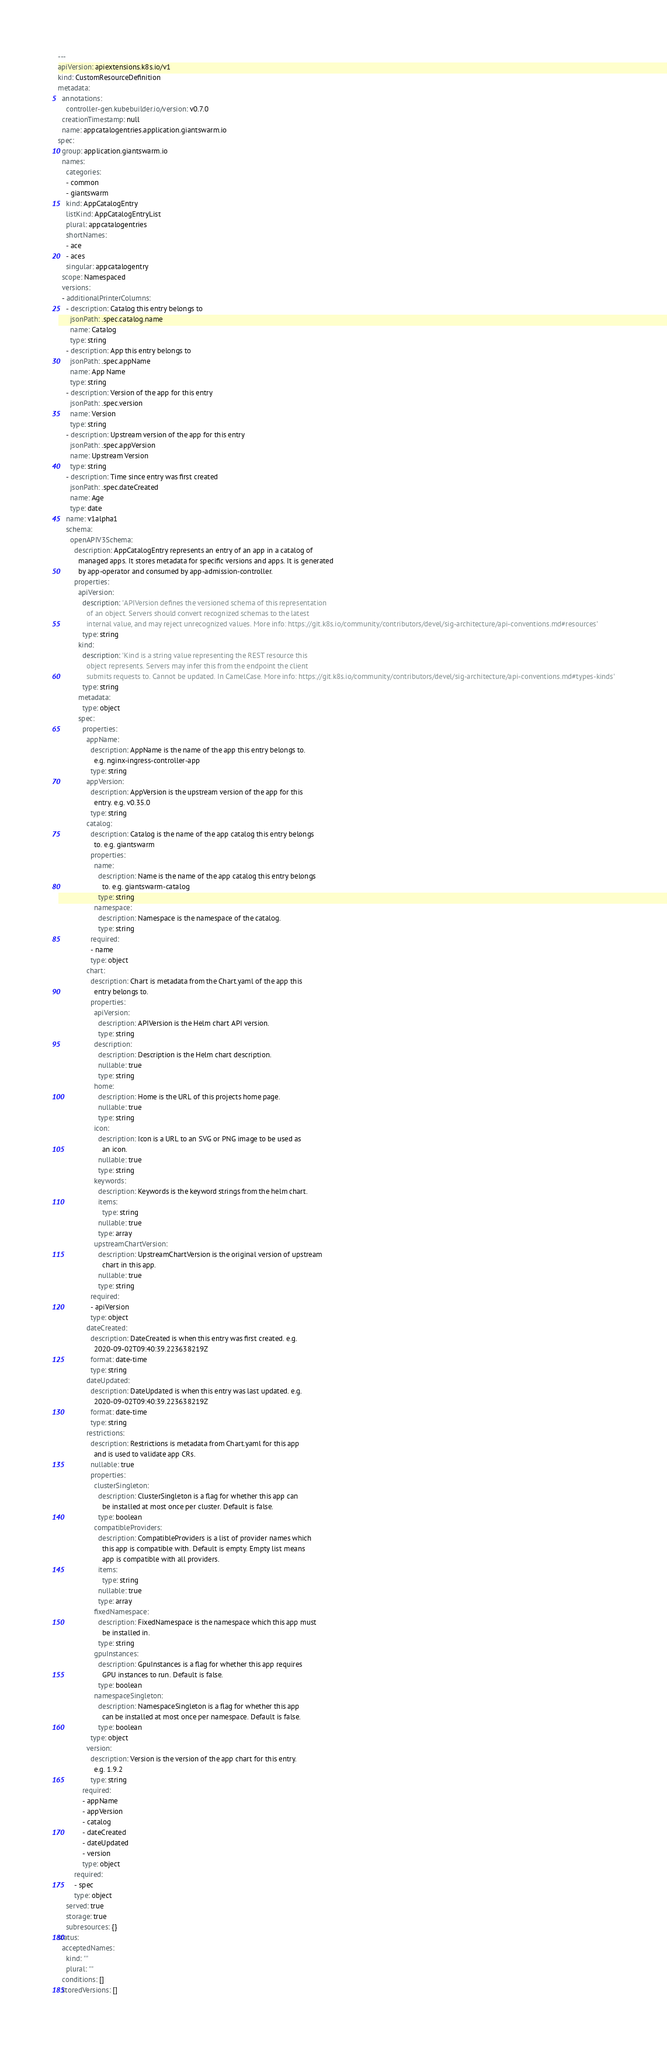<code> <loc_0><loc_0><loc_500><loc_500><_YAML_>
---
apiVersion: apiextensions.k8s.io/v1
kind: CustomResourceDefinition
metadata:
  annotations:
    controller-gen.kubebuilder.io/version: v0.7.0
  creationTimestamp: null
  name: appcatalogentries.application.giantswarm.io
spec:
  group: application.giantswarm.io
  names:
    categories:
    - common
    - giantswarm
    kind: AppCatalogEntry
    listKind: AppCatalogEntryList
    plural: appcatalogentries
    shortNames:
    - ace
    - aces
    singular: appcatalogentry
  scope: Namespaced
  versions:
  - additionalPrinterColumns:
    - description: Catalog this entry belongs to
      jsonPath: .spec.catalog.name
      name: Catalog
      type: string
    - description: App this entry belongs to
      jsonPath: .spec.appName
      name: App Name
      type: string
    - description: Version of the app for this entry
      jsonPath: .spec.version
      name: Version
      type: string
    - description: Upstream version of the app for this entry
      jsonPath: .spec.appVersion
      name: Upstream Version
      type: string
    - description: Time since entry was first created
      jsonPath: .spec.dateCreated
      name: Age
      type: date
    name: v1alpha1
    schema:
      openAPIV3Schema:
        description: AppCatalogEntry represents an entry of an app in a catalog of
          managed apps. It stores metadata for specific versions and apps. It is generated
          by app-operator and consumed by app-admission-controller.
        properties:
          apiVersion:
            description: 'APIVersion defines the versioned schema of this representation
              of an object. Servers should convert recognized schemas to the latest
              internal value, and may reject unrecognized values. More info: https://git.k8s.io/community/contributors/devel/sig-architecture/api-conventions.md#resources'
            type: string
          kind:
            description: 'Kind is a string value representing the REST resource this
              object represents. Servers may infer this from the endpoint the client
              submits requests to. Cannot be updated. In CamelCase. More info: https://git.k8s.io/community/contributors/devel/sig-architecture/api-conventions.md#types-kinds'
            type: string
          metadata:
            type: object
          spec:
            properties:
              appName:
                description: AppName is the name of the app this entry belongs to.
                  e.g. nginx-ingress-controller-app
                type: string
              appVersion:
                description: AppVersion is the upstream version of the app for this
                  entry. e.g. v0.35.0
                type: string
              catalog:
                description: Catalog is the name of the app catalog this entry belongs
                  to. e.g. giantswarm
                properties:
                  name:
                    description: Name is the name of the app catalog this entry belongs
                      to. e.g. giantswarm-catalog
                    type: string
                  namespace:
                    description: Namespace is the namespace of the catalog.
                    type: string
                required:
                - name
                type: object
              chart:
                description: Chart is metadata from the Chart.yaml of the app this
                  entry belongs to.
                properties:
                  apiVersion:
                    description: APIVersion is the Helm chart API version.
                    type: string
                  description:
                    description: Description is the Helm chart description.
                    nullable: true
                    type: string
                  home:
                    description: Home is the URL of this projects home page.
                    nullable: true
                    type: string
                  icon:
                    description: Icon is a URL to an SVG or PNG image to be used as
                      an icon.
                    nullable: true
                    type: string
                  keywords:
                    description: Keywords is the keyword strings from the helm chart.
                    items:
                      type: string
                    nullable: true
                    type: array
                  upstreamChartVersion:
                    description: UpstreamChartVersion is the original version of upstream
                      chart in this app.
                    nullable: true
                    type: string
                required:
                - apiVersion
                type: object
              dateCreated:
                description: DateCreated is when this entry was first created. e.g.
                  2020-09-02T09:40:39.223638219Z
                format: date-time
                type: string
              dateUpdated:
                description: DateUpdated is when this entry was last updated. e.g.
                  2020-09-02T09:40:39.223638219Z
                format: date-time
                type: string
              restrictions:
                description: Restrictions is metadata from Chart.yaml for this app
                  and is used to validate app CRs.
                nullable: true
                properties:
                  clusterSingleton:
                    description: ClusterSingleton is a flag for whether this app can
                      be installed at most once per cluster. Default is false.
                    type: boolean
                  compatibleProviders:
                    description: CompatibleProviders is a list of provider names which
                      this app is compatible with. Default is empty. Empty list means
                      app is compatible with all providers.
                    items:
                      type: string
                    nullable: true
                    type: array
                  fixedNamespace:
                    description: FixedNamespace is the namespace which this app must
                      be installed in.
                    type: string
                  gpuInstances:
                    description: GpuInstances is a flag for whether this app requires
                      GPU instances to run. Default is false.
                    type: boolean
                  namespaceSingleton:
                    description: NamespaceSingleton is a flag for whether this app
                      can be installed at most once per namespace. Default is false.
                    type: boolean
                type: object
              version:
                description: Version is the version of the app chart for this entry.
                  e.g. 1.9.2
                type: string
            required:
            - appName
            - appVersion
            - catalog
            - dateCreated
            - dateUpdated
            - version
            type: object
        required:
        - spec
        type: object
    served: true
    storage: true
    subresources: {}
status:
  acceptedNames:
    kind: ""
    plural: ""
  conditions: []
  storedVersions: []
</code> 